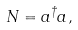<formula> <loc_0><loc_0><loc_500><loc_500>N = a ^ { \dagger } a ,</formula> 